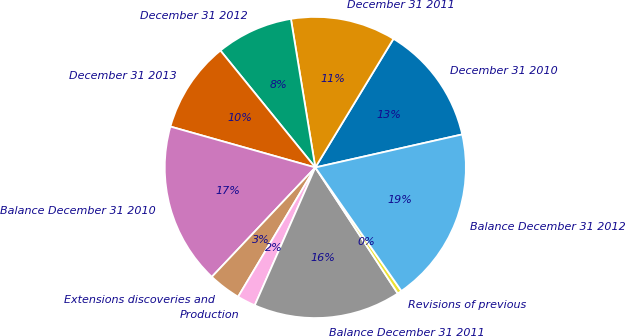<chart> <loc_0><loc_0><loc_500><loc_500><pie_chart><fcel>December 31 2010<fcel>December 31 2011<fcel>December 31 2012<fcel>December 31 2013<fcel>Balance December 31 2010<fcel>Extensions discoveries and<fcel>Production<fcel>Balance December 31 2011<fcel>Revisions of previous<fcel>Balance December 31 2012<nl><fcel>12.79%<fcel>11.28%<fcel>8.26%<fcel>9.77%<fcel>17.32%<fcel>3.49%<fcel>1.98%<fcel>15.81%<fcel>0.47%<fcel>18.83%<nl></chart> 